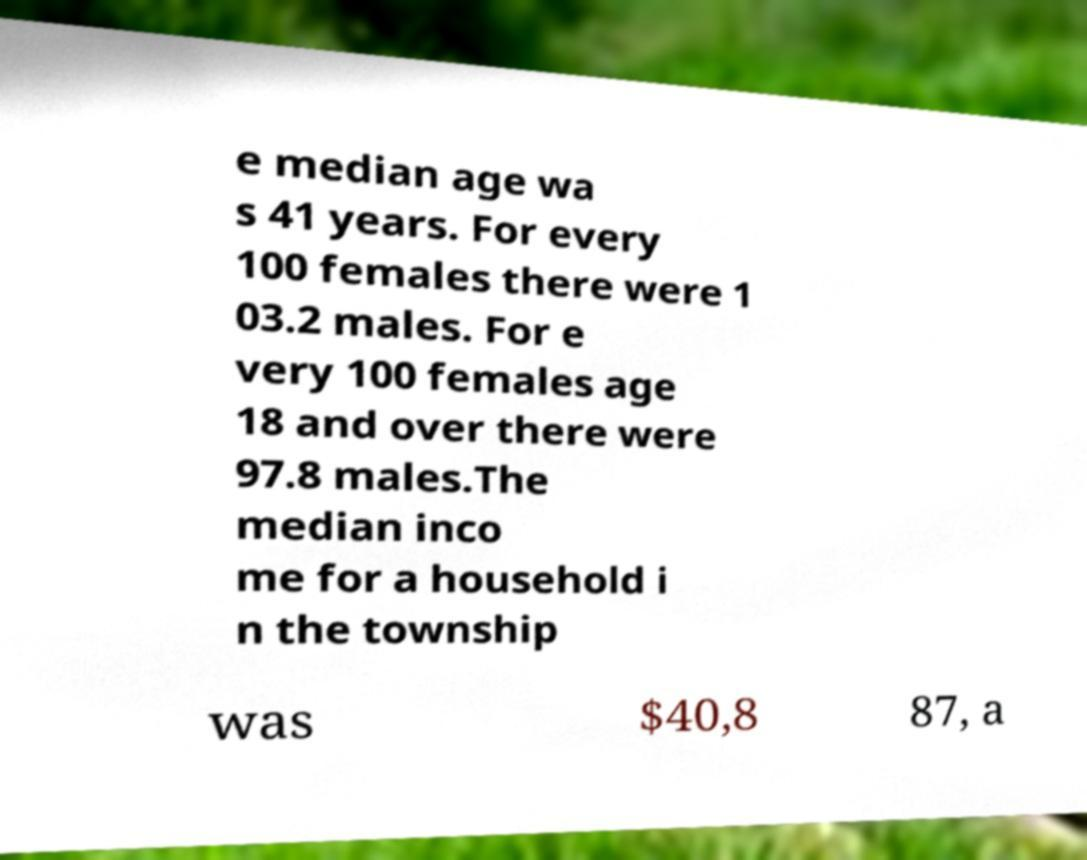There's text embedded in this image that I need extracted. Can you transcribe it verbatim? e median age wa s 41 years. For every 100 females there were 1 03.2 males. For e very 100 females age 18 and over there were 97.8 males.The median inco me for a household i n the township was $40,8 87, a 